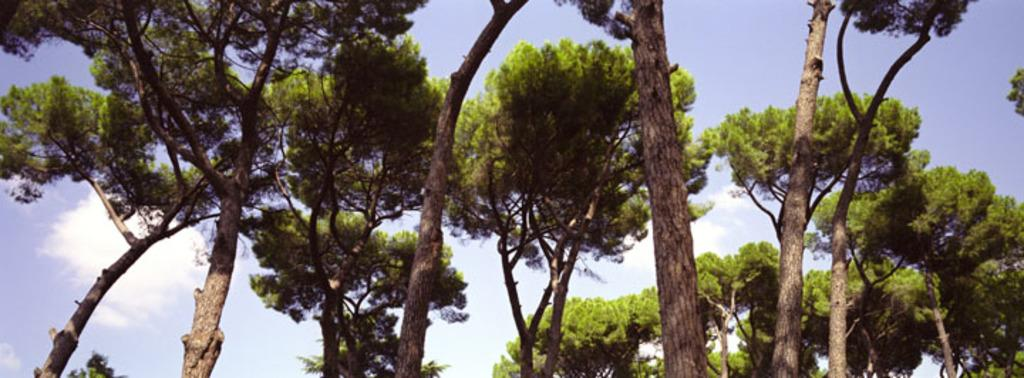What type of vegetation is in the foreground of the image? There are trees in the foreground of the image. What part of the natural environment is visible in the background of the image? The sky is visible in the background of the image. Can you see a pear hanging from one of the trees in the image? There is no pear visible in the image; only trees are present in the foreground. 